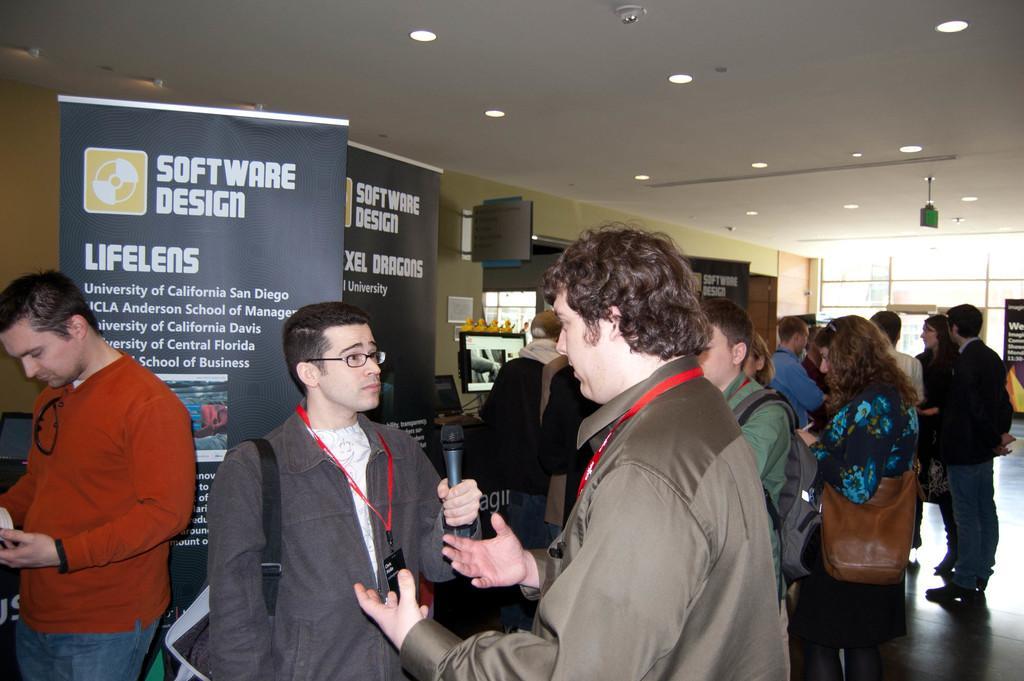Please provide a concise description of this image. In this image I can see a group of people are standing on the floor and few are holding some objects in their hand. In the background I can see boards, posters, wall, window, lights and screen. This image is taken may be in a hall. 